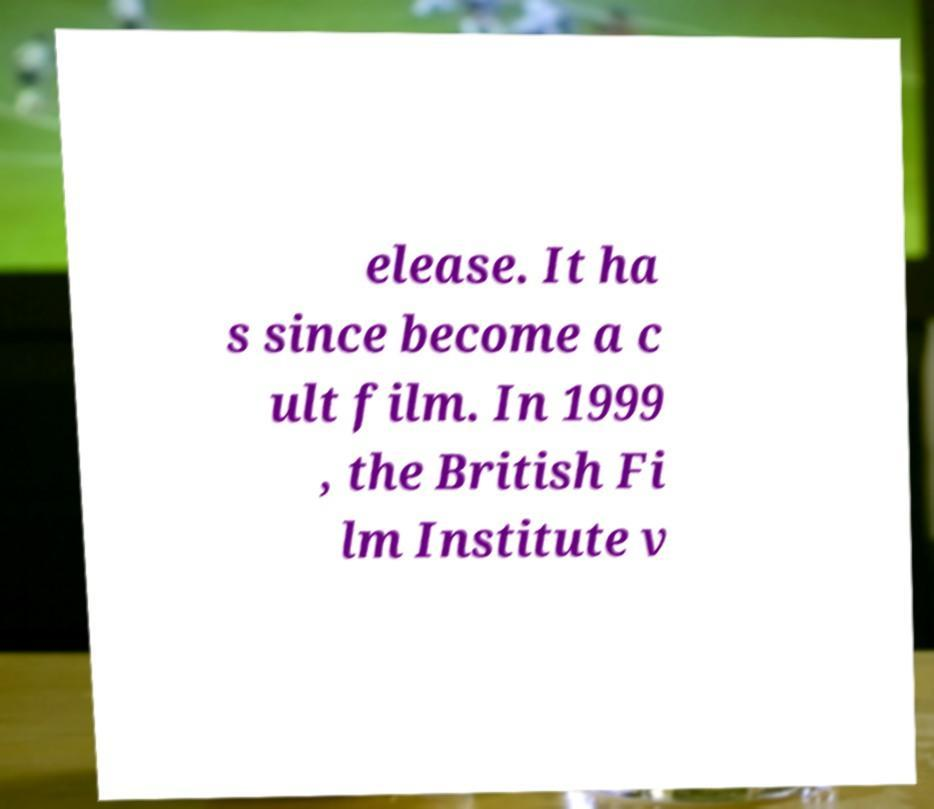Could you assist in decoding the text presented in this image and type it out clearly? elease. It ha s since become a c ult film. In 1999 , the British Fi lm Institute v 